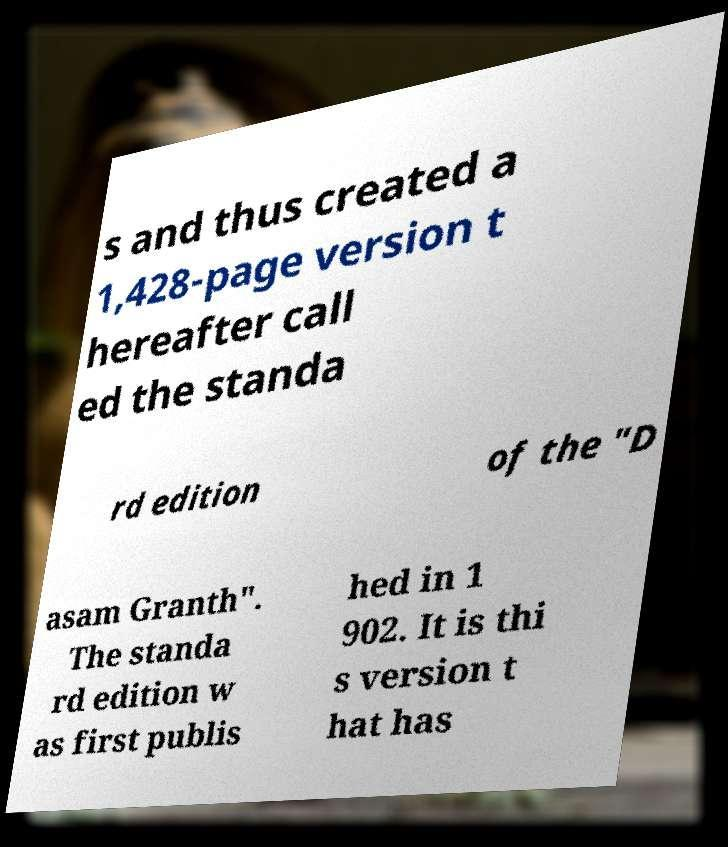Could you extract and type out the text from this image? s and thus created a 1,428-page version t hereafter call ed the standa rd edition of the "D asam Granth". The standa rd edition w as first publis hed in 1 902. It is thi s version t hat has 